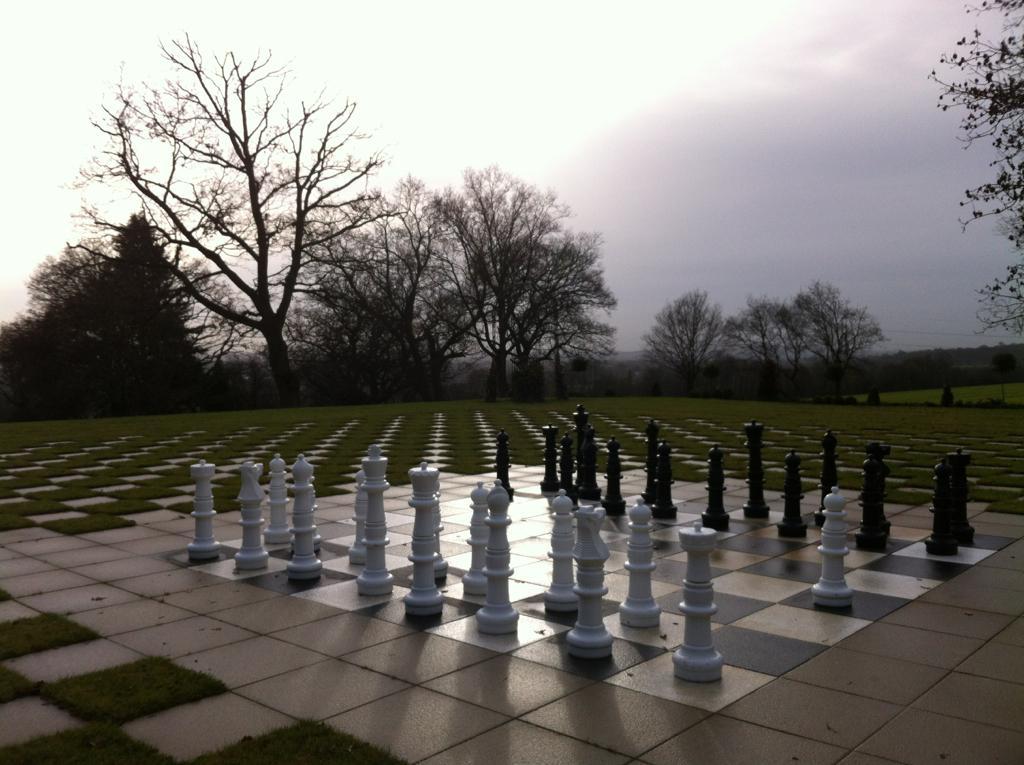Please provide a concise description of this image. Sky is cloudy. Here we can see chess pieces on the surface. Background there are trees. 